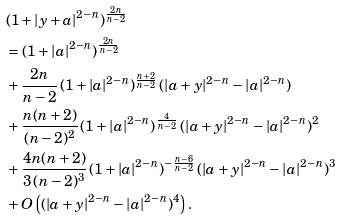Convert formula to latex. <formula><loc_0><loc_0><loc_500><loc_500>& ( 1 + | y + a | ^ { 2 - n } ) ^ { \frac { 2 n } { n - 2 } } \\ & = ( 1 + | a | ^ { 2 - n } ) ^ { \frac { 2 n } { n - 2 } } \\ & + \frac { 2 n } { n - 2 } \, ( 1 + | a | ^ { 2 - n } ) ^ { \frac { n + 2 } { n - 2 } } \, ( | a + y | ^ { 2 - n } - | a | ^ { 2 - n } ) \\ & + \frac { n ( n + 2 ) } { ( n - 2 ) ^ { 2 } } \, ( 1 + | a | ^ { 2 - n } ) ^ { \frac { 4 } { n - 2 } } \, ( | a + y | ^ { 2 - n } - | a | ^ { 2 - n } ) ^ { 2 } \\ & + \frac { 4 n ( n + 2 ) } { 3 \, ( n - 2 ) ^ { 3 } } \, ( 1 + | a | ^ { 2 - n } ) ^ { - \frac { n - 6 } { n - 2 } } \, ( | a + y | ^ { 2 - n } - | a | ^ { 2 - n } ) ^ { 3 } \\ & + O \left ( ( | a + y | ^ { 2 - n } - | a | ^ { 2 - n } ) ^ { 4 } \right ) .</formula> 